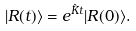<formula> <loc_0><loc_0><loc_500><loc_500>| R ( t ) \rangle = e ^ { \hat { K } t } | R ( 0 ) \rangle .</formula> 